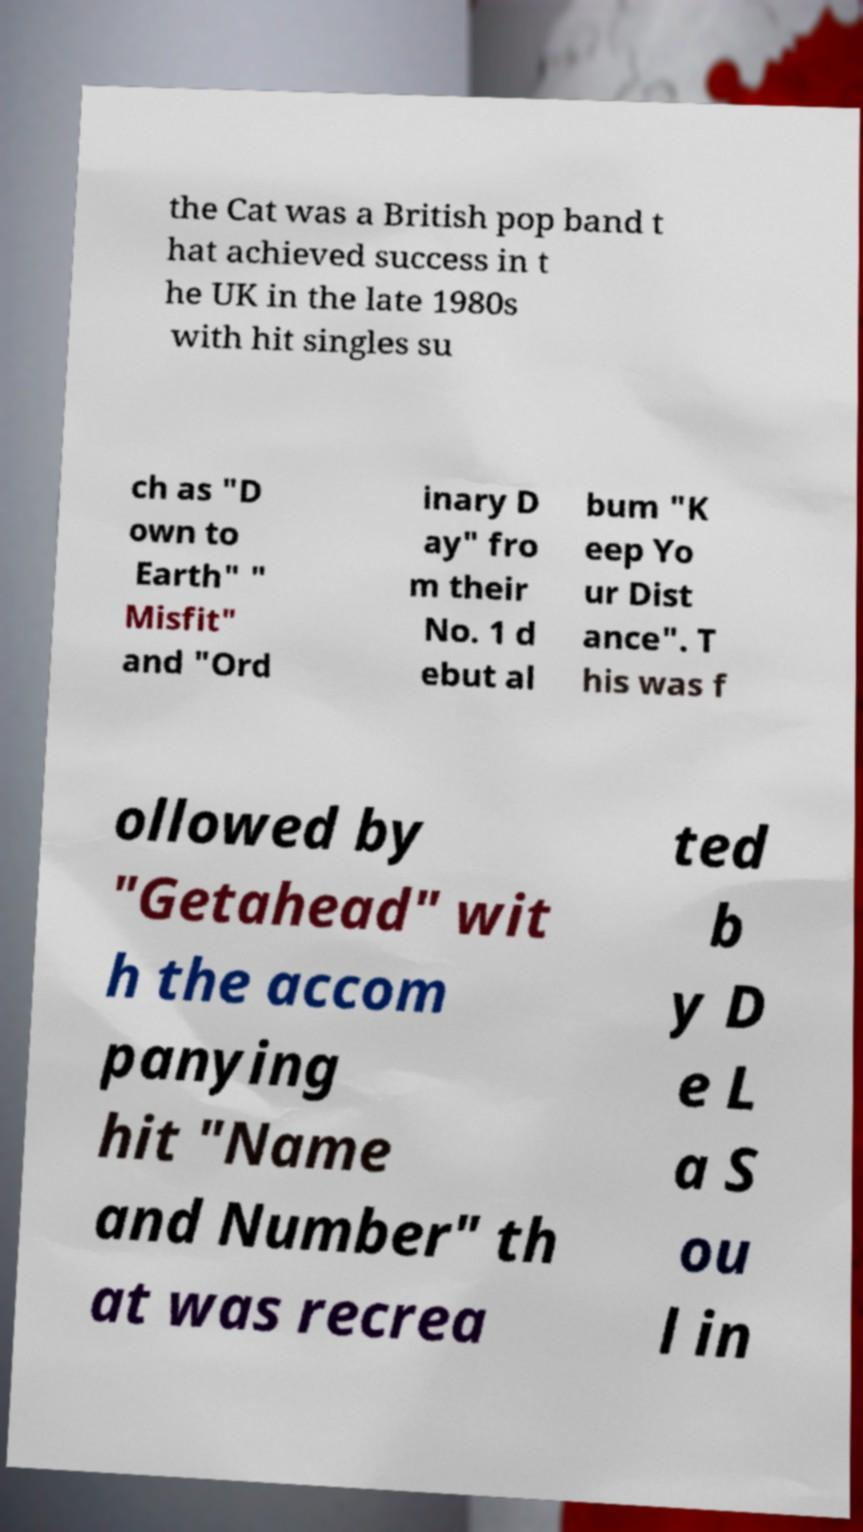Can you read and provide the text displayed in the image?This photo seems to have some interesting text. Can you extract and type it out for me? the Cat was a British pop band t hat achieved success in t he UK in the late 1980s with hit singles su ch as "D own to Earth" " Misfit" and "Ord inary D ay" fro m their No. 1 d ebut al bum "K eep Yo ur Dist ance". T his was f ollowed by "Getahead" wit h the accom panying hit "Name and Number" th at was recrea ted b y D e L a S ou l in 